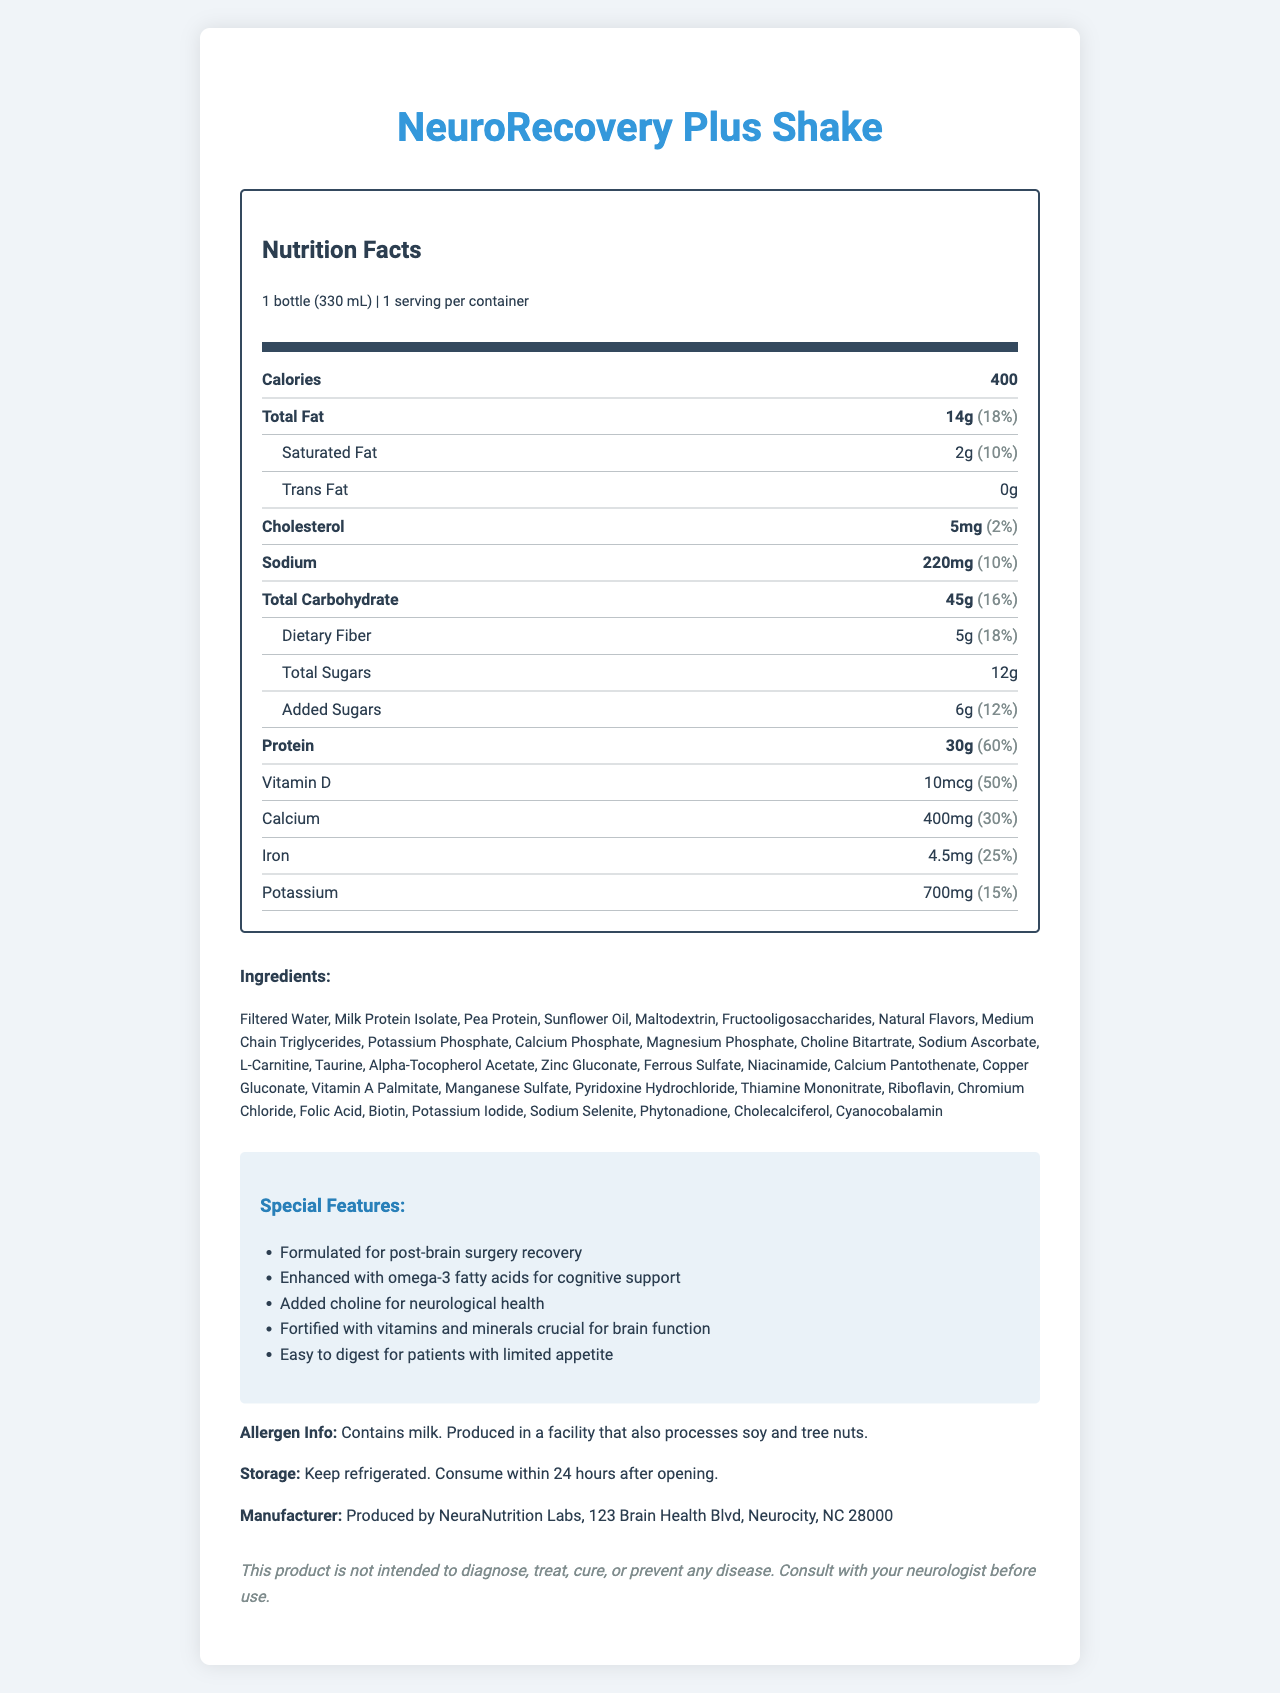what is the serving size of the NeuroRecovery Plus Shake? The serving size is clearly mentioned as "1 bottle (330 mL)" in the document.
Answer: 1 bottle (330 mL) how much protein is in one serving of the shake? The document states that one serving contains 30 grams of protein.
Answer: 30g how many calories are in one bottle of the NeuroRecovery Plus Shake? The document mentions that one serving (1 bottle) contains 400 calories.
Answer: 400 calories is there any trans fat in the shake? The trans fat content is listed as "0g" in the document, which means there is no trans fat in the shake.
Answer: No how much vitamin D does the shake provide per serving? The document specifies that the shake provides 10 micrograms of vitamin D per serving.
Answer: 10mcg which mineral has the highest Daily Value percentage in the shake? The minerals with the highest Daily Value percentages are Thiamin, Riboflavin, Niacin, Vitamin B6, Folate, Vitamin B12, Biotin, and Pantothenic Acid, all at 100%.
Answer: Thiamin, Riboflavin, Niacin, Vitamin B6, Folate, Vitamin B12, Biotin, Pantothenic Acid (100%) how many grams of total fat does the NeuroRecovery Plus Shake contain? The total fat content per serving is 14 grams as specified in the document.
Answer: 14g which of the following vitamins is NOT included in the shake? A. Vitamin D B. Vitamin K C. Vitamin B5 D. Vitamin B7 E. Vitamin C The shake contains all the listed vitamins, but Vitamin B5 is listed as Pantothenic Acid in the document.
Answer: C. Vitamin B5 what is the primary ingredient in the NeuroRecovery Plus Shake? The first ingredient listed in the document is Filtered Water, indicating it is the primary ingredient.
Answer: Filtered Water how many servings are there per container of the shake? The document clearly mentions that there is 1 serving per container.
Answer: 1 is the NeuroRecovery Plus Shake gluten-free? The document does not provide any information about the gluten content of the shake.
Answer: Cannot be determined how should the NeuroRecovery Plus Shake be stored? The storage instructions in the document specify that the shake should be kept refrigerated and consumed within 24 hours after opening.
Answer: Keep refrigerated. Consume within 24 hours after opening. is the NeuroRecovery Plus Shake specifically formulated for post-brain surgery recovery? The document lists one of the special features as "Formulated for post-brain surgery recovery."
Answer: Yes what special ingredient in the shake supports cognitive function? The document mentions that the shake is "Enhanced with omega-3 fatty acids for cognitive support."
Answer: Omega-3 fatty acids who produces the NeuroRecovery Plus Shake? The manufacturer's information specifies that the shake is produced by NeuraNutrition Labs.
Answer: NeuraNutrition Labs summarize the main idea of the document. The document is primarily focused on conveying the nutritional benefits and specialized formulation of the NeuroRecovery Plus Shake for supporting brain health and recovery, along with practical details like ingredients, storage, and manufacturing information.
Answer: The document provides detailed nutrition facts and special features of the NeuroRecovery Plus Shake, a nutrient-dense meal replacement formulated for patients recovering from brain surgery. It includes information on serving size, nutritional content, ingredients, storage instructions, and manufacturer details. 